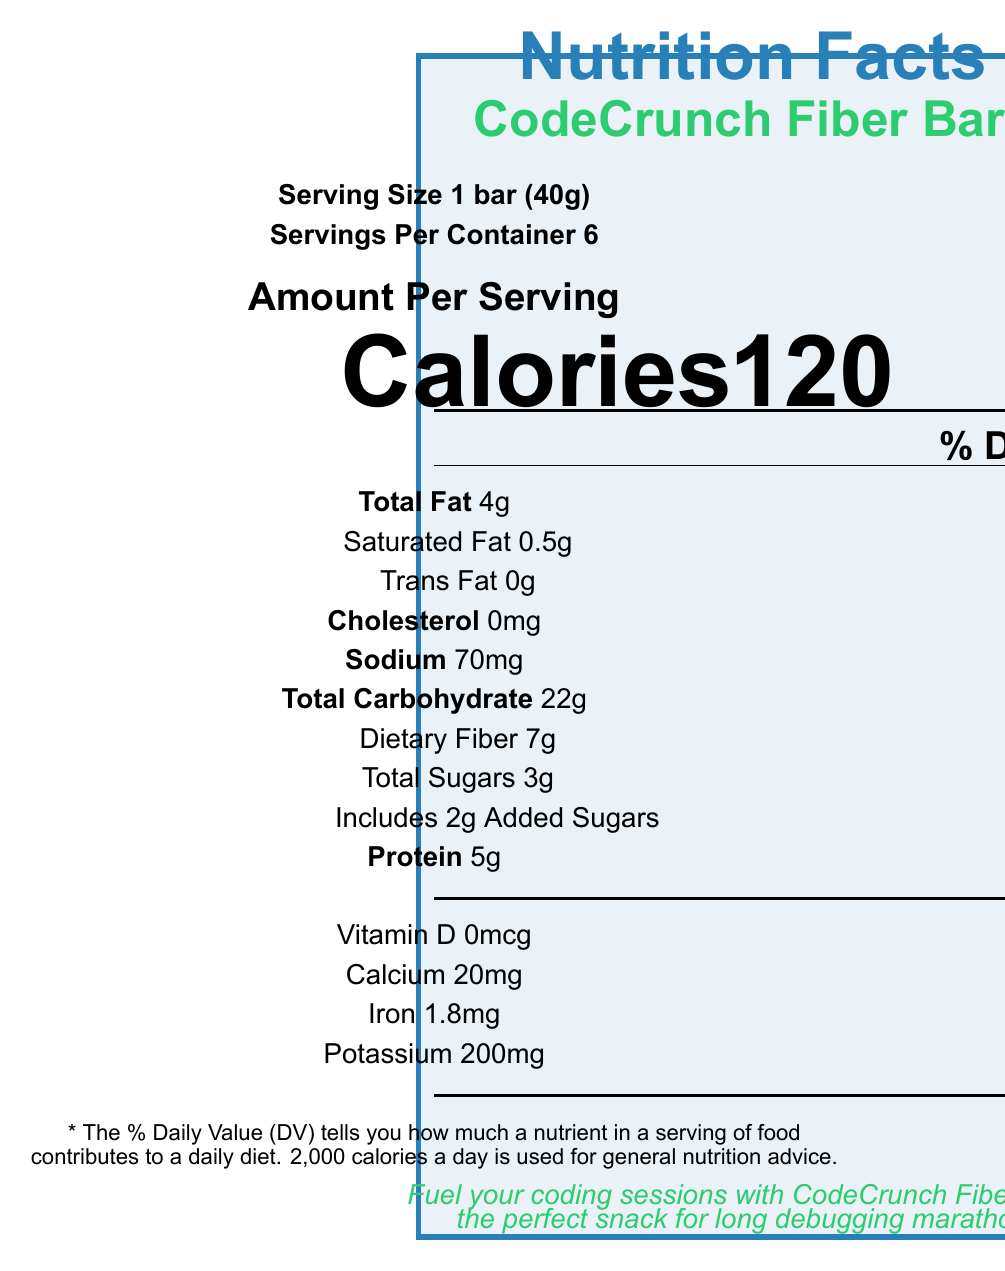what is the serving size of CodeCrunch Fiber Bars? The serving size is clearly mentioned in the document as "1 bar (40g)".
Answer: 1 bar (40g) how many grams of dietary fiber does one serving contain? The document lists 7g of dietary fiber per serving.
Answer: 7g how many calories are in one CodeCrunch Fiber Bar? The calorie content per serving (1 bar) is stated as 120.
Answer: 120 what is the total amount of protein in one serving? The protein amount per serving is given as 5g.
Answer: 5g how much sodium is in a single serving? The amount of sodium per serving is stated as 70mg.
Answer: 70mg what is the percent daily value of iron in one bar? The document indicates that one bar contains 10% of the daily value of iron.
Answer: 10% multiple-choice: which of the following nutrients has the highest percent daily value in one serving? A. Total Fat B. Dietary Fiber C. Iron D. Calcium The percent daily value of dietary fiber is 25%, which is the highest compared to Total Fat (5%), Iron (10%), and Calcium (2%).
Answer: B. Dietary Fiber multiple-choice: what health claims are associated with CodeCrunch Fiber Bars?
I. Good source of fiber
II. Low in sodium
III. Low in sugar
IV. No artificial sweeteners
A. I and II
B. I, III, and IV
C. II and IV
D. I, II, III, and IV The document states that the bars are a "Good source of fiber", "Low in sugar", and contain "No artificial sweeteners".
Answer: B. I, III, and IV yes/no: does the product contain any trans fat? The document shows "Trans Fat 0g," indicating there is no trans fat in the product.
Answer: No how many servings are in a container of CodeCrunch Fiber Bars? The document mentions that there are 6 servings per container.
Answer: 6 what are the allergens listed in the document? The document clearly states "Contains almonds" as the allergen information.
Answer: Almonds describe the main idea of the document. The document contains nutritional details, ingredient list, allergen information, health claims, and promotional messages for CodeCrunch Fiber Bars, aimed at coding bootcamp attendees.
Answer: The document provides detailed nutrition information for CodeCrunch Fiber Bars, highlighting they are low in sugar, high in fiber, and suitable for coding bootcamps. The bars are promoted as a healthy snack option for long coding sessions and are endorsed by a professor from the Computer Science Department. how much added sugars are present in one serving? The document specifies that the amount of added sugars in one serving is 2g.
Answer: 2g can the exact number of coding bootcamps using CodeCrunch Fiber Bars be determined from the document? The document promotes the bars for coding bootcamps but does not provide any numerical data on the number of bootcamps using them.
Answer: Not enough information 